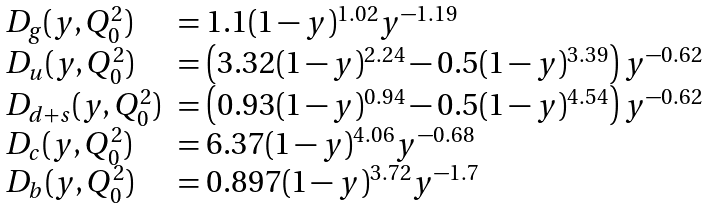<formula> <loc_0><loc_0><loc_500><loc_500>\begin{array} { l l } D _ { g } ( y , Q _ { 0 } ^ { 2 } ) & = 1 . 1 ( 1 - y ) ^ { 1 . 0 2 } y ^ { - 1 . 1 9 } \\ D _ { u } ( y , Q _ { 0 } ^ { 2 } ) & = \left ( 3 . 3 2 ( 1 - y ) ^ { 2 . 2 4 } - 0 . 5 ( 1 - y ) ^ { 3 . 3 9 } \right ) y ^ { - 0 . 6 2 } \\ D _ { d + s } ( y , Q _ { 0 } ^ { 2 } ) & = \left ( 0 . 9 3 ( 1 - y ) ^ { 0 . 9 4 } - 0 . 5 ( 1 - y ) ^ { 4 . 5 4 } \right ) y ^ { - 0 . 6 2 } \\ D _ { c } ( y , Q _ { 0 } ^ { 2 } ) & = 6 . 3 7 ( 1 - y ) ^ { 4 . 0 6 } y ^ { - 0 . 6 8 } \\ D _ { b } ( y , Q _ { 0 } ^ { 2 } ) & = 0 . 8 9 7 ( 1 - y ) ^ { 3 . 7 2 } y ^ { - 1 . 7 } \\ \end{array}</formula> 